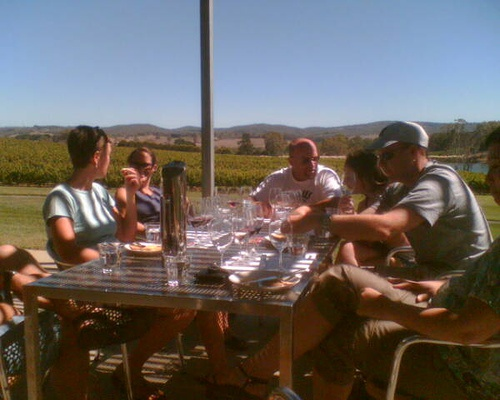Describe the objects in this image and their specific colors. I can see dining table in darkgray, gray, and maroon tones, people in darkgray, black, maroon, and gray tones, people in darkgray, black, maroon, gray, and olive tones, people in darkgray, maroon, black, gray, and lightgray tones, and people in darkgray, maroon, brown, and gray tones in this image. 